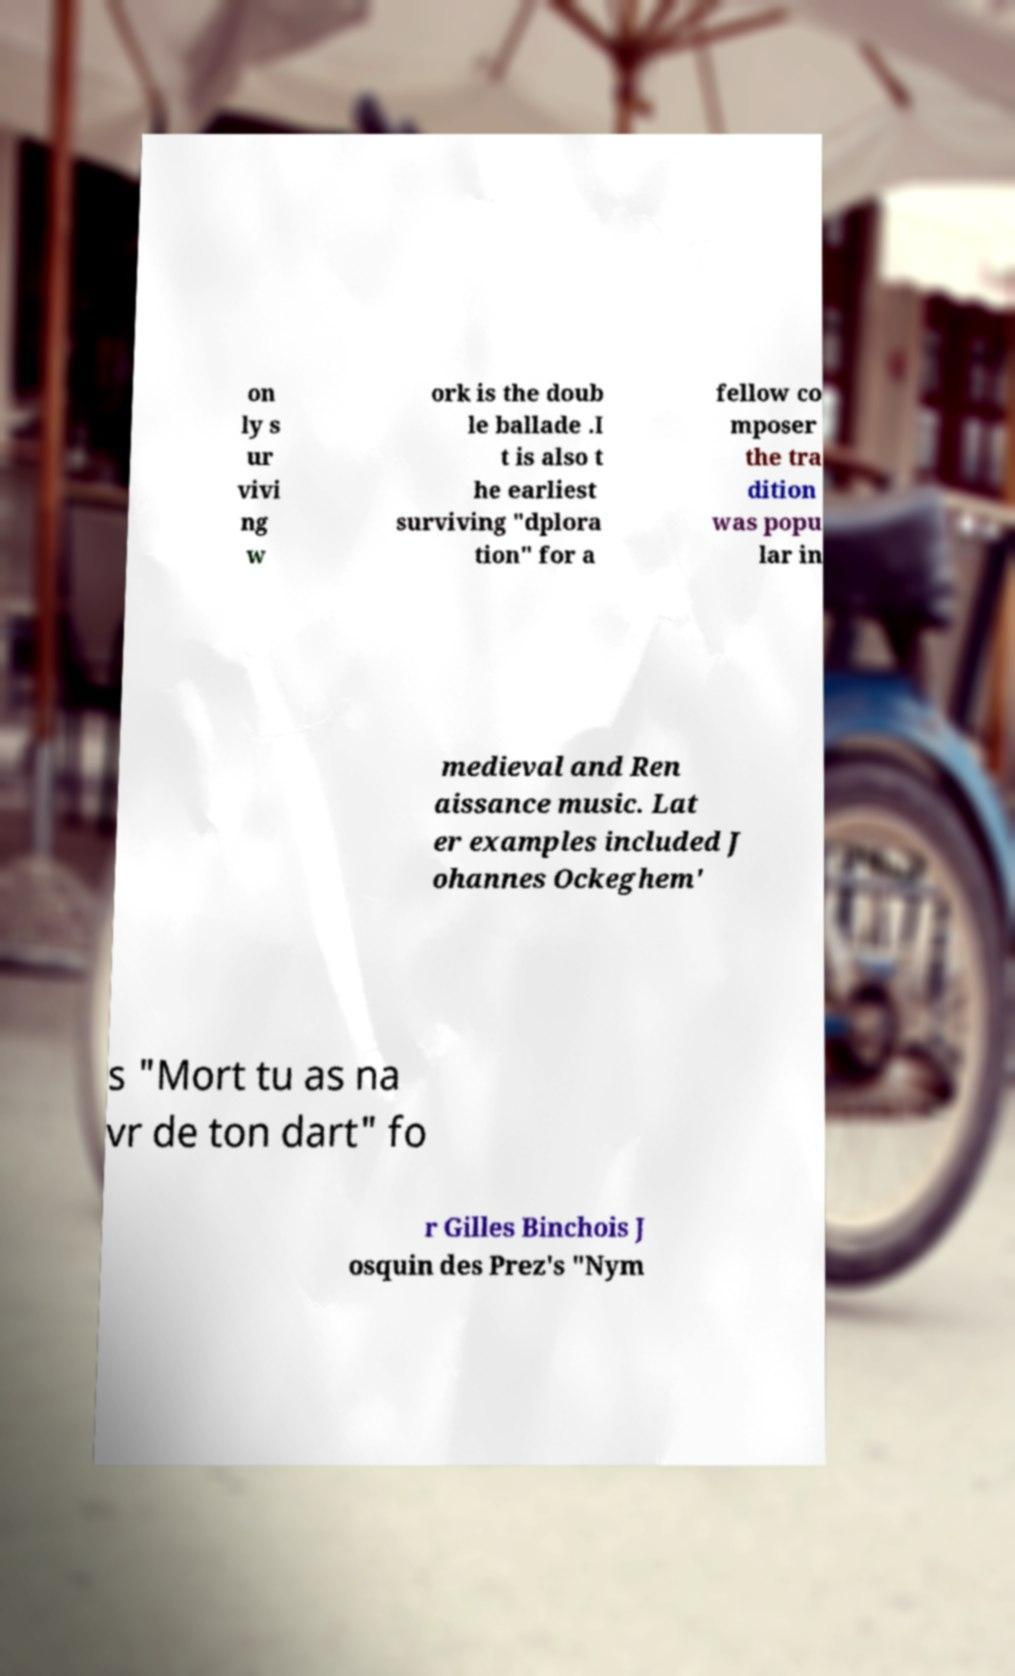I need the written content from this picture converted into text. Can you do that? on ly s ur vivi ng w ork is the doub le ballade .I t is also t he earliest surviving "dplora tion" for a fellow co mposer the tra dition was popu lar in medieval and Ren aissance music. Lat er examples included J ohannes Ockeghem' s "Mort tu as na vr de ton dart" fo r Gilles Binchois J osquin des Prez's "Nym 